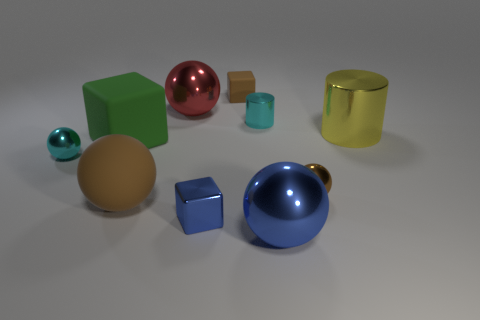Subtract all matte cubes. How many cubes are left? 1 Subtract all blue spheres. How many spheres are left? 4 Subtract all blue balls. Subtract all blue cubes. How many balls are left? 4 Subtract all cylinders. How many objects are left? 8 Add 6 rubber blocks. How many rubber blocks are left? 8 Add 1 large gray metal balls. How many large gray metal balls exist? 1 Subtract 1 cyan balls. How many objects are left? 9 Subtract all large cyan rubber objects. Subtract all tiny blue metallic objects. How many objects are left? 9 